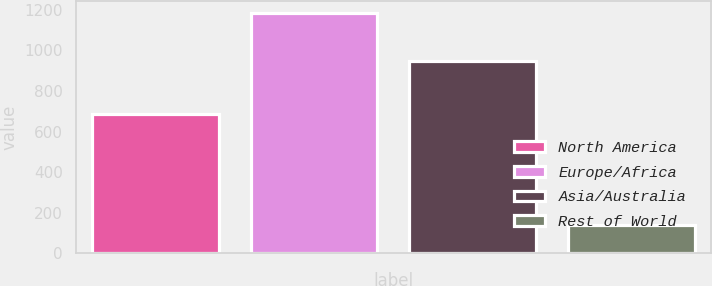Convert chart. <chart><loc_0><loc_0><loc_500><loc_500><bar_chart><fcel>North America<fcel>Europe/Africa<fcel>Asia/Australia<fcel>Rest of World<nl><fcel>685<fcel>1183<fcel>946<fcel>141<nl></chart> 